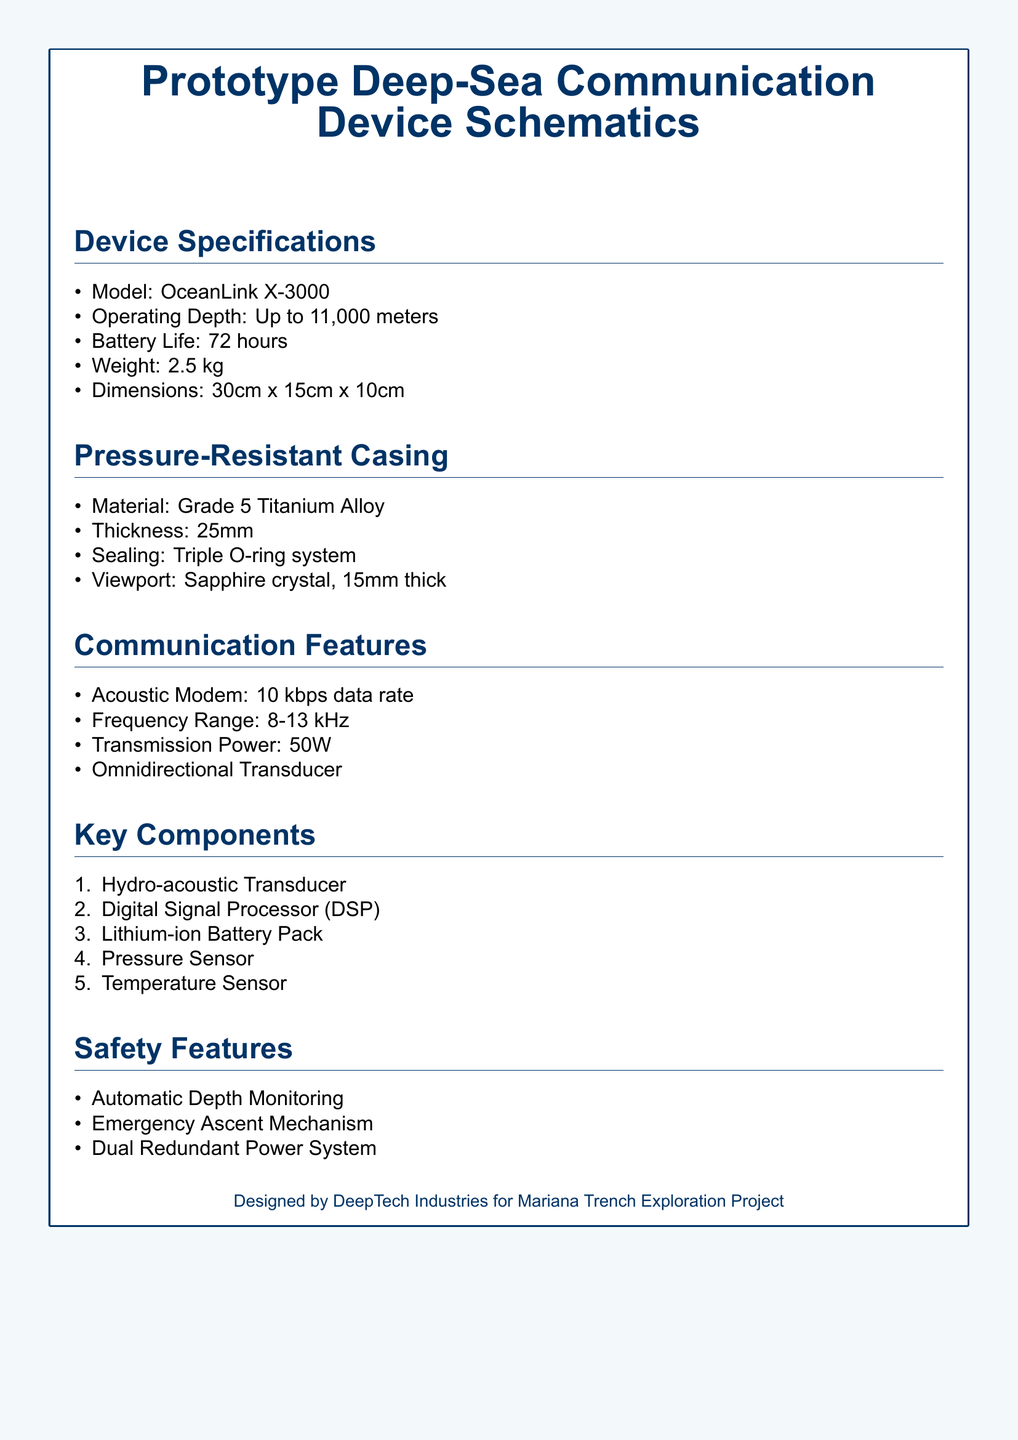What is the model of the device? The model of the device is stated under the specifications section of the document.
Answer: OceanLink X-3000 What is the operating depth of the device? The operating depth is indicated in the device specifications section, stating how deep it can function.
Answer: Up to 11,000 meters What is the thickness of the pressure-resistant casing? The thickness is specified in the pressure-resistant casing section, detailing the construction of the device.
Answer: 25mm What is the data rate of the acoustic modem? The data rate is found in the communication features section, indicating its efficiency.
Answer: 10 kbps What safety feature monitors depth? The depth monitoring safety feature is mentioned in the safety features section, highlighting important safeguards.
Answer: Automatic Depth Monitoring How many key components are listed in the document? The document provides a count of the key components associated with the device, which is crucial for functionality.
Answer: 5 What material is used for the casing? The material used for the casing is specified, which is a critical factor for pressure resistance.
Answer: Grade 5 Titanium Alloy What is the battery life of the device? The battery life is mentioned under the device specifications, indicating its operational duration.
Answer: 72 hours What is the power of the transmission? The transmission power is described in the communication features section, showing the device's capability.
Answer: 50W 